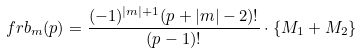Convert formula to latex. <formula><loc_0><loc_0><loc_500><loc_500>\ f r b _ { m } ( p ) = \frac { ( - 1 ) ^ { | m | + 1 } ( p + | m | - 2 ) ! } { ( p - 1 ) ! } \cdot \left \{ M _ { 1 } + M _ { 2 } \right \}</formula> 